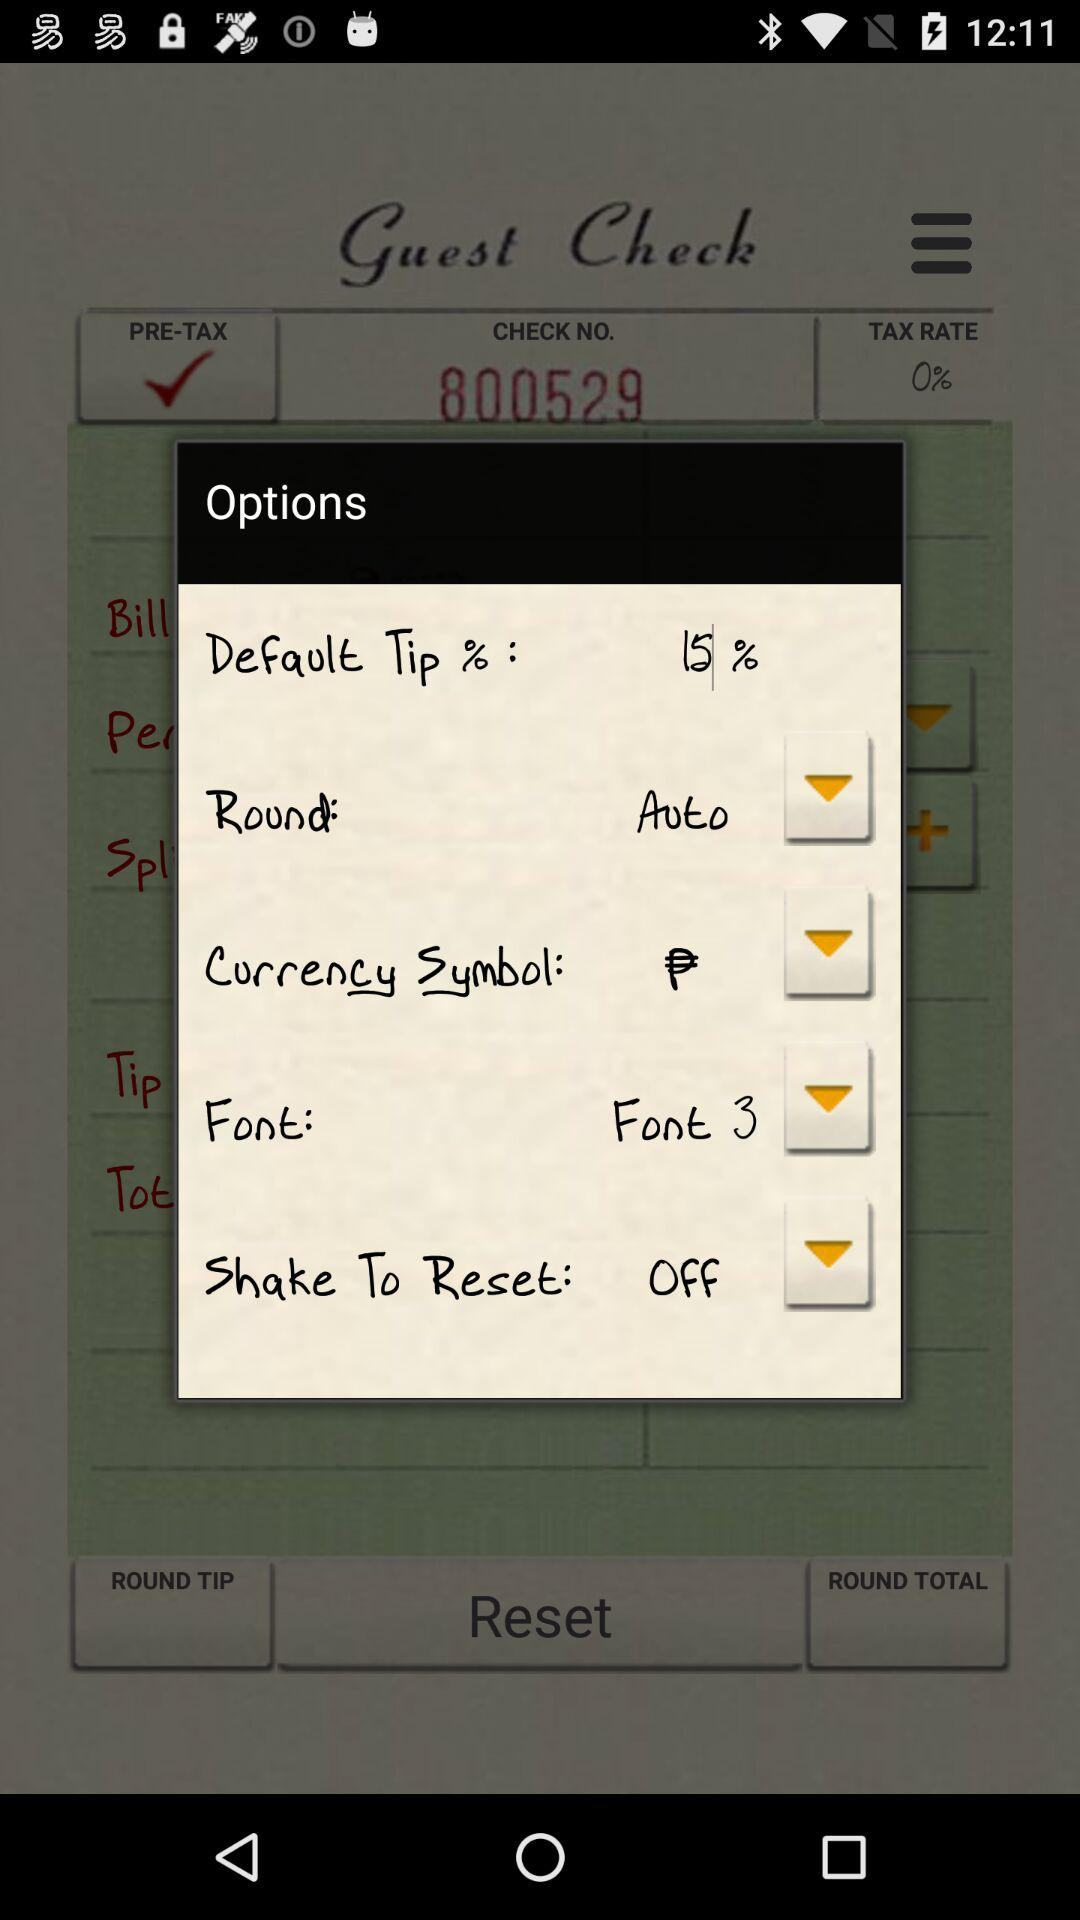What is the default tip percentage? The default tip percentage is 15. 